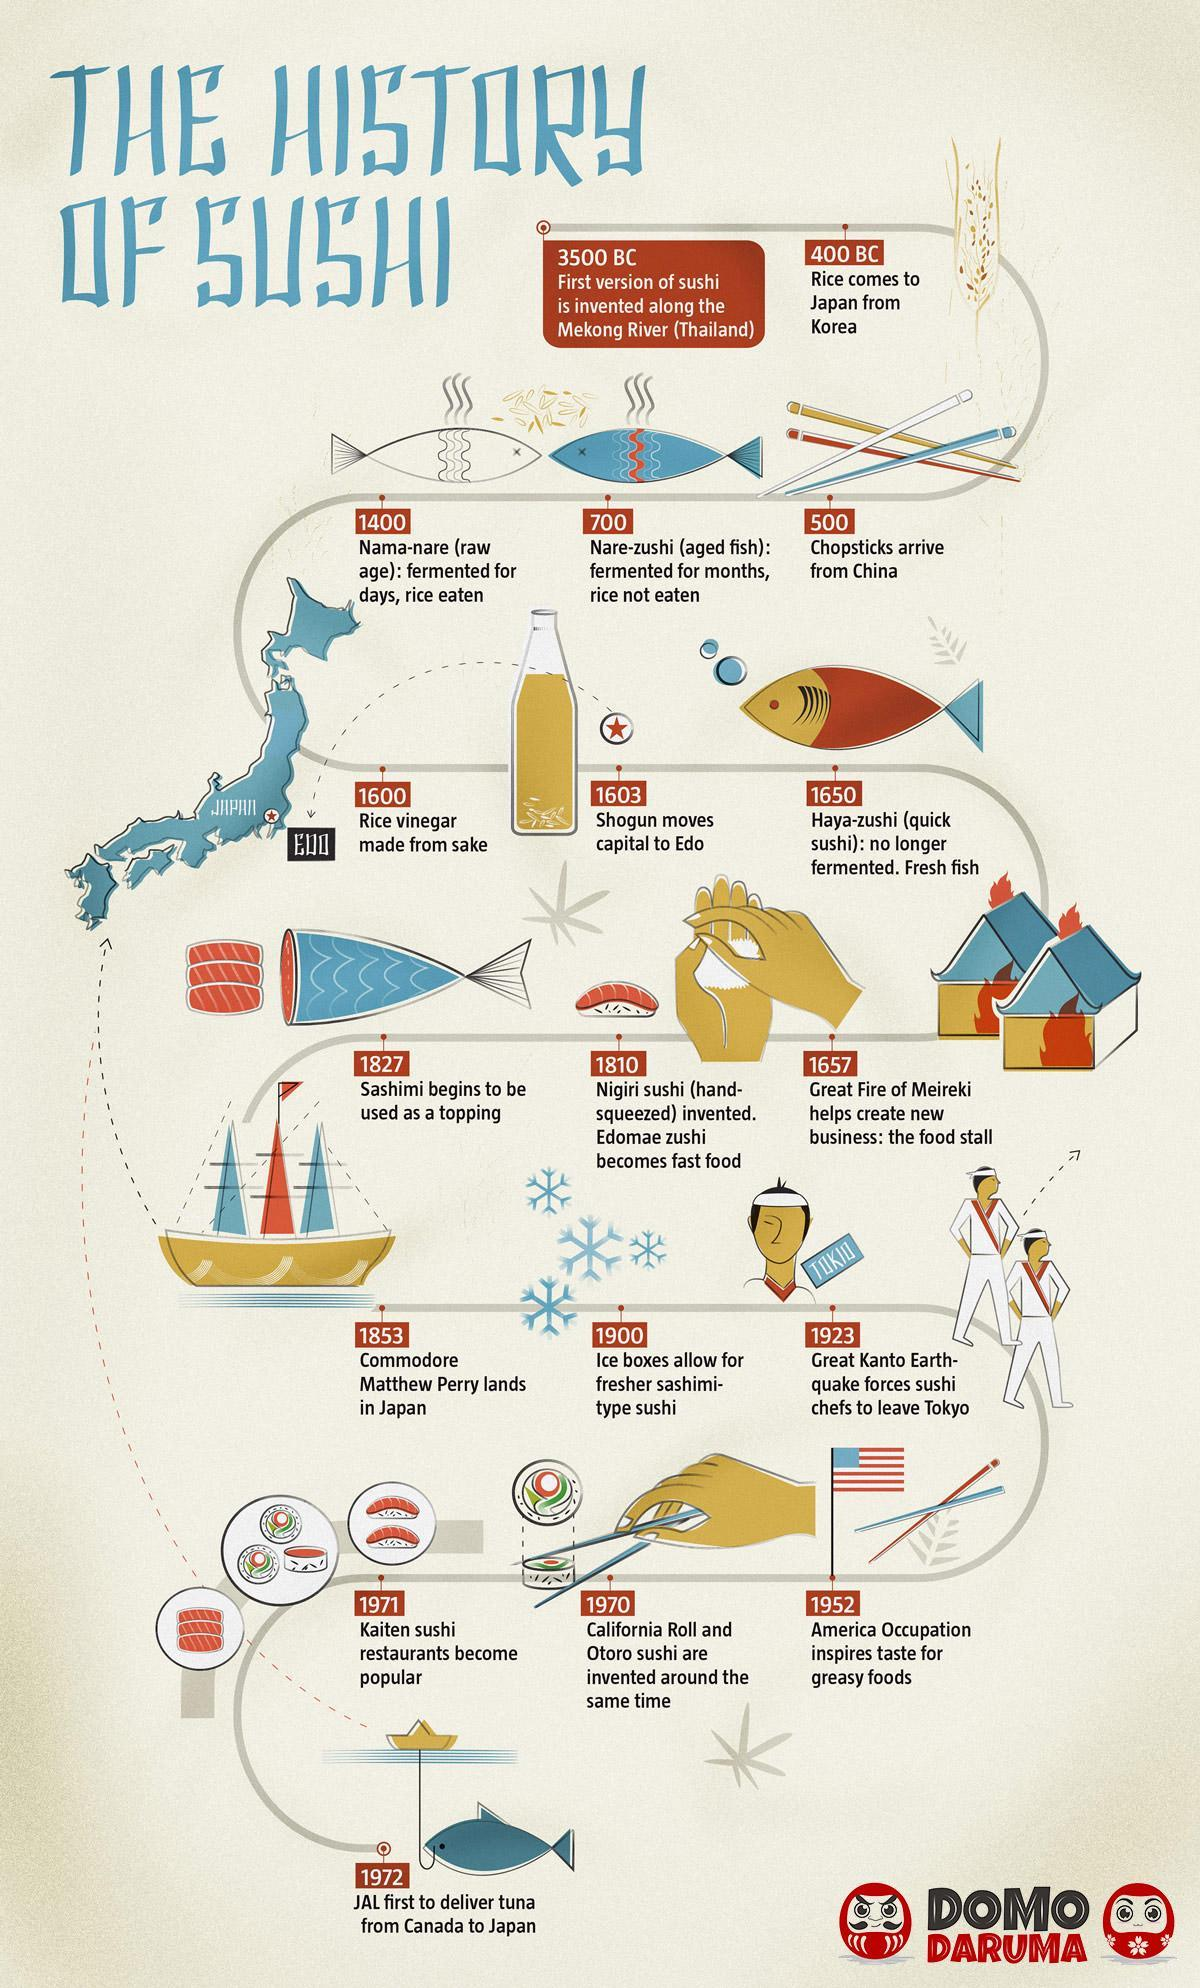From which place did rice arrive?
Answer the question with a short phrase. Korea In which year did sushi chefs leave Tokyo? 1923 In which year was chopsticks introduced in Japan? 500 In the earliest forms of sushi the fish was - fermented or fresh? fermented In which year was the food stall created? 1657 Which US naval officer arrived in Japan? Commodore Mathew Perry What helped keep sushi fresher? ice boxes By which year was fresh fish used in sushi? 1650 